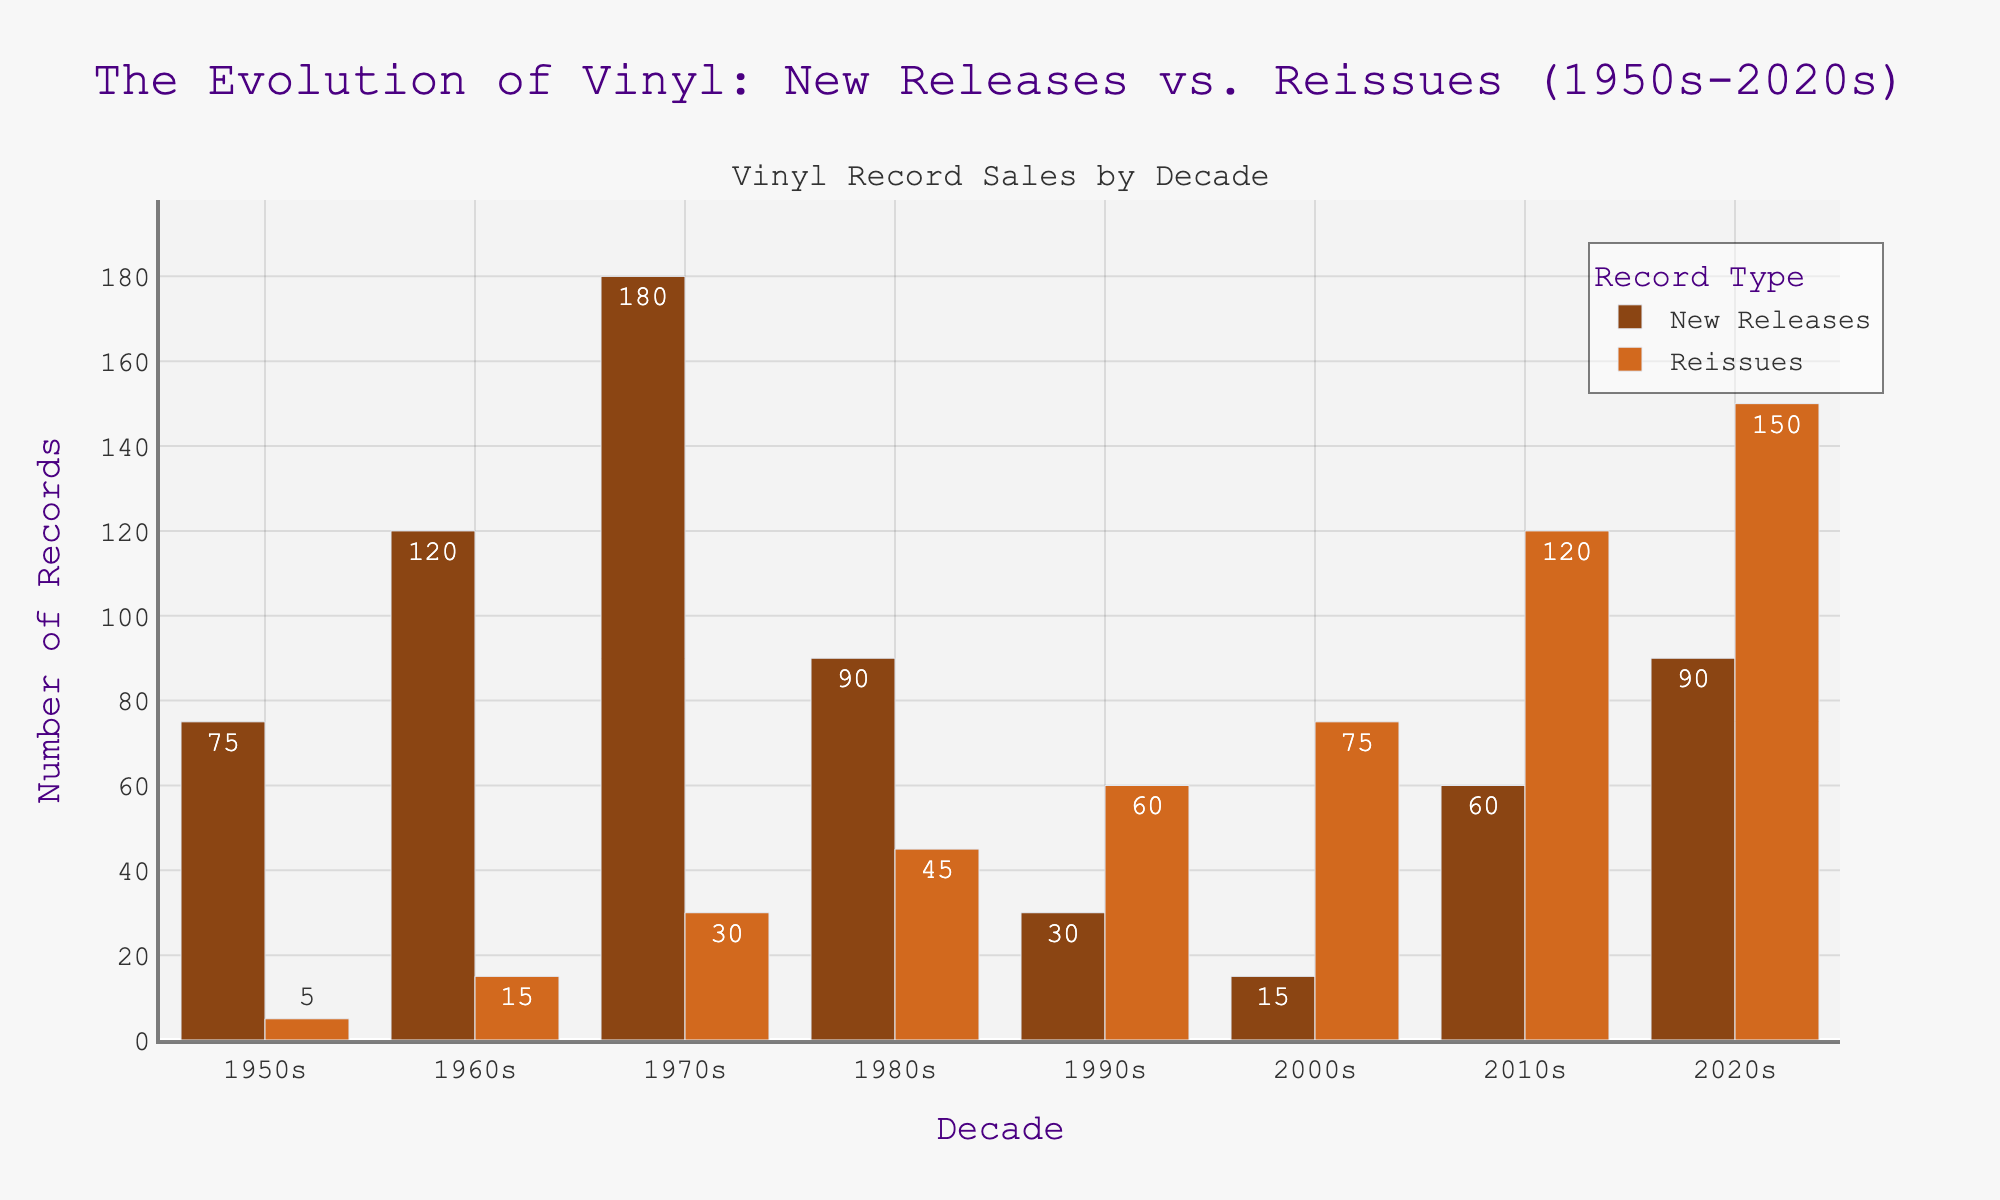what is the total number of vinyl record sales (both new releases and reissues) in the 1970s? Sum the new releases (180) and reissues (30) in the 1970s to get the total number of vinyl record sales. 180 + 30 = 210
Answer: 210 Which decade had the highest number of new releases? Compare the number of new releases sold in each decade. The 1970s had the highest number with 180 new releases.
Answer: 1970s How much higher is the number of reissues in the 2020s compared to the 1990s? Subtract the number of reissues in the 1990s (60) from the number of reissues in the 2020s (150). 150 - 60 = 90
Answer: 90 In which decade is the difference between new releases and reissues the smallest? Calculate the difference between new releases and reissues for each decade. The smallest difference is in the 1950s, with 75 - 5 = 70.
Answer: 1950s What is the average number of new releases per decade from the 1950s to the 2020s? Sum the number of new releases from all decades (75 + 120 + 180 + 90 + 30 + 15 + 60 + 90 = 660) and divide by the number of decades (8). 660 / 8 = 82.5
Answer: 82.5 Which decade showed the largest increase in the number of reissues compared to the previous decade? Compare the increase in reissues for each consecutive decade. The largest increase is from the 2010s (120) to the 2020s (150), an increase of 30.
Answer: 2020s What is the overall trend in the number of reissues from the 1950s to the 2020s? Observe the reissue numbers: 5, 15, 30, 45, 60, 75, 120, 150. The trend shows a consistent increase over the decades.
Answer: Increasing How many more reissues were sold in the 2010s compared to new releases? Subtract the number of new releases in the 2010s (60) from the number of reissues (120) in the same decade. 120 - 60 = 60
Answer: 60 What visual cue helps to differentiate new releases from reissues in the chart? Note that new releases are represented by bars with a unique brown color and reissues by a different shade of brown.
Answer: Bar color Between which two consecutive decades did the number of new releases drop the most? Calculate the decrease in new releases between each consecutive decade and identify the largest drop. From the 1970s (180) to the 1980s (90), there is a drop of 90.
Answer: 1970s to 1980s 